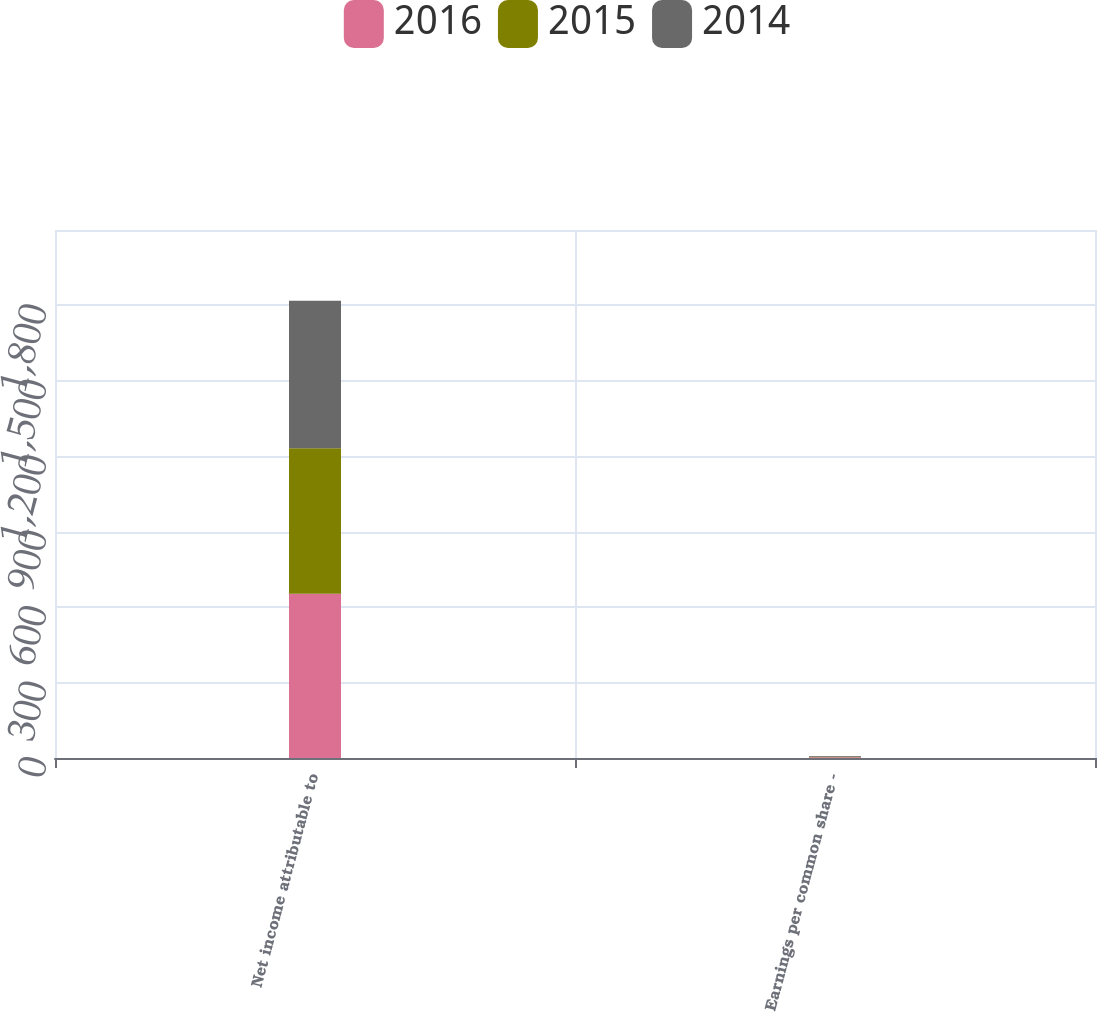<chart> <loc_0><loc_0><loc_500><loc_500><stacked_bar_chart><ecel><fcel>Net income attributable to<fcel>Earnings per common share -<nl><fcel>2016<fcel>653<fcel>2.68<nl><fcel>2015<fcel>579<fcel>2.38<nl><fcel>2014<fcel>587<fcel>2.4<nl></chart> 